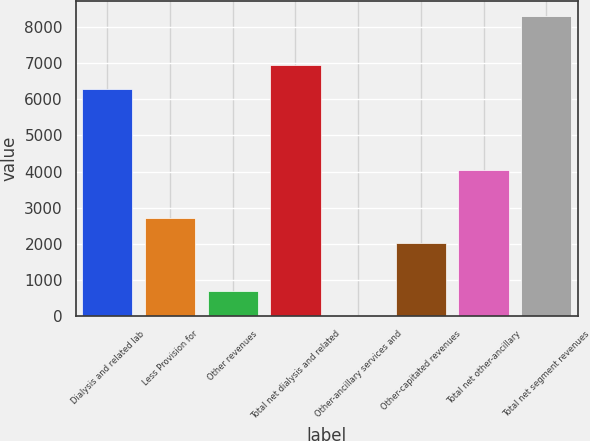<chart> <loc_0><loc_0><loc_500><loc_500><bar_chart><fcel>Dialysis and related lab<fcel>Less Provision for<fcel>Other revenues<fcel>Total net dialysis and related<fcel>Other-ancillary services and<fcel>Other-capitated revenues<fcel>Total net other-ancillary<fcel>Total net segment revenues<nl><fcel>6284<fcel>2704.4<fcel>682.1<fcel>6958.1<fcel>8<fcel>2030.3<fcel>4052.6<fcel>8306.3<nl></chart> 